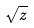Convert formula to latex. <formula><loc_0><loc_0><loc_500><loc_500>\sqrt { z }</formula> 